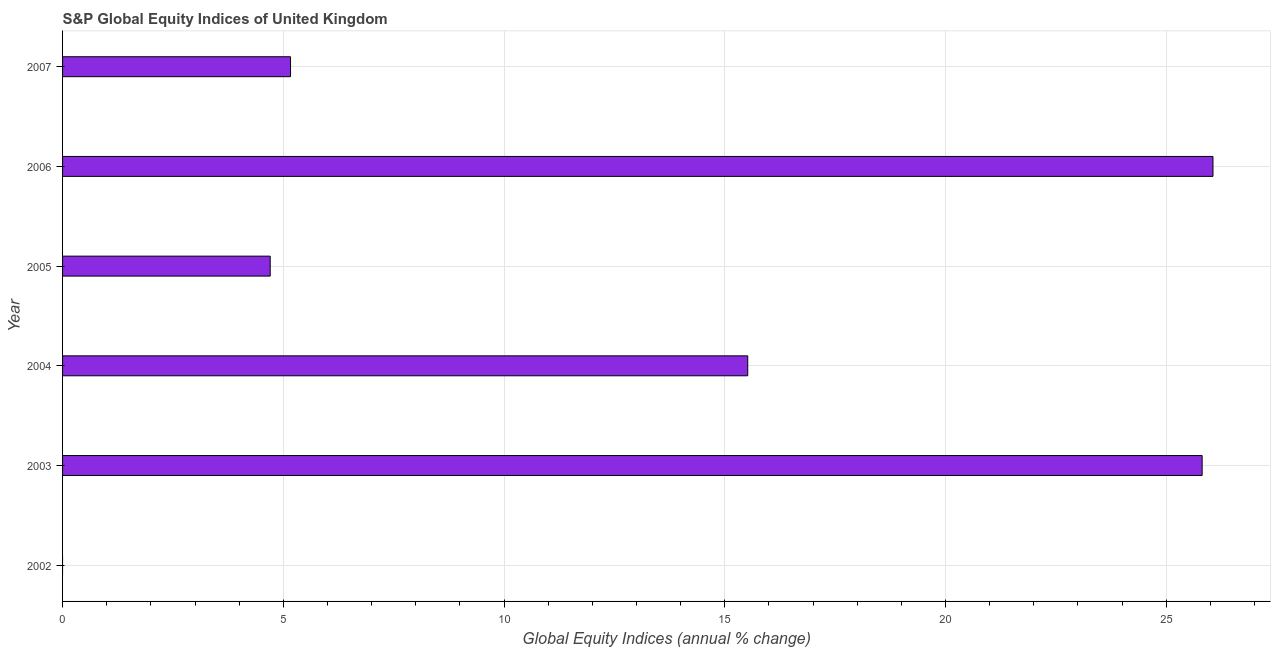Does the graph contain any zero values?
Provide a short and direct response. Yes. What is the title of the graph?
Your answer should be compact. S&P Global Equity Indices of United Kingdom. What is the label or title of the X-axis?
Offer a terse response. Global Equity Indices (annual % change). What is the label or title of the Y-axis?
Ensure brevity in your answer.  Year. What is the s&p global equity indices in 2003?
Give a very brief answer. 25.81. Across all years, what is the maximum s&p global equity indices?
Make the answer very short. 26.06. Across all years, what is the minimum s&p global equity indices?
Offer a very short reply. 0. In which year was the s&p global equity indices maximum?
Offer a terse response. 2006. What is the sum of the s&p global equity indices?
Provide a short and direct response. 77.26. What is the difference between the s&p global equity indices in 2004 and 2006?
Your response must be concise. -10.54. What is the average s&p global equity indices per year?
Provide a short and direct response. 12.88. What is the median s&p global equity indices?
Provide a succinct answer. 10.34. What is the ratio of the s&p global equity indices in 2003 to that in 2007?
Give a very brief answer. 5. Is the difference between the s&p global equity indices in 2003 and 2007 greater than the difference between any two years?
Offer a very short reply. No. What is the difference between the highest and the second highest s&p global equity indices?
Your answer should be very brief. 0.24. Is the sum of the s&p global equity indices in 2003 and 2006 greater than the maximum s&p global equity indices across all years?
Ensure brevity in your answer.  Yes. What is the difference between the highest and the lowest s&p global equity indices?
Your answer should be very brief. 26.06. Are all the bars in the graph horizontal?
Keep it short and to the point. Yes. What is the difference between two consecutive major ticks on the X-axis?
Your response must be concise. 5. Are the values on the major ticks of X-axis written in scientific E-notation?
Offer a very short reply. No. What is the Global Equity Indices (annual % change) of 2003?
Keep it short and to the point. 25.81. What is the Global Equity Indices (annual % change) of 2004?
Offer a very short reply. 15.52. What is the Global Equity Indices (annual % change) in 2005?
Your answer should be compact. 4.7. What is the Global Equity Indices (annual % change) in 2006?
Keep it short and to the point. 26.06. What is the Global Equity Indices (annual % change) of 2007?
Your response must be concise. 5.16. What is the difference between the Global Equity Indices (annual % change) in 2003 and 2004?
Provide a short and direct response. 10.29. What is the difference between the Global Equity Indices (annual % change) in 2003 and 2005?
Your answer should be compact. 21.11. What is the difference between the Global Equity Indices (annual % change) in 2003 and 2006?
Keep it short and to the point. -0.25. What is the difference between the Global Equity Indices (annual % change) in 2003 and 2007?
Your answer should be compact. 20.65. What is the difference between the Global Equity Indices (annual % change) in 2004 and 2005?
Offer a very short reply. 10.82. What is the difference between the Global Equity Indices (annual % change) in 2004 and 2006?
Give a very brief answer. -10.54. What is the difference between the Global Equity Indices (annual % change) in 2004 and 2007?
Provide a short and direct response. 10.36. What is the difference between the Global Equity Indices (annual % change) in 2005 and 2006?
Keep it short and to the point. -21.35. What is the difference between the Global Equity Indices (annual % change) in 2005 and 2007?
Your answer should be compact. -0.46. What is the difference between the Global Equity Indices (annual % change) in 2006 and 2007?
Your answer should be compact. 20.89. What is the ratio of the Global Equity Indices (annual % change) in 2003 to that in 2004?
Keep it short and to the point. 1.66. What is the ratio of the Global Equity Indices (annual % change) in 2003 to that in 2005?
Offer a very short reply. 5.49. What is the ratio of the Global Equity Indices (annual % change) in 2003 to that in 2006?
Offer a terse response. 0.99. What is the ratio of the Global Equity Indices (annual % change) in 2003 to that in 2007?
Your response must be concise. 5. What is the ratio of the Global Equity Indices (annual % change) in 2004 to that in 2005?
Provide a short and direct response. 3.3. What is the ratio of the Global Equity Indices (annual % change) in 2004 to that in 2006?
Offer a terse response. 0.6. What is the ratio of the Global Equity Indices (annual % change) in 2004 to that in 2007?
Your answer should be very brief. 3.01. What is the ratio of the Global Equity Indices (annual % change) in 2005 to that in 2006?
Ensure brevity in your answer.  0.18. What is the ratio of the Global Equity Indices (annual % change) in 2005 to that in 2007?
Provide a short and direct response. 0.91. What is the ratio of the Global Equity Indices (annual % change) in 2006 to that in 2007?
Offer a terse response. 5.05. 